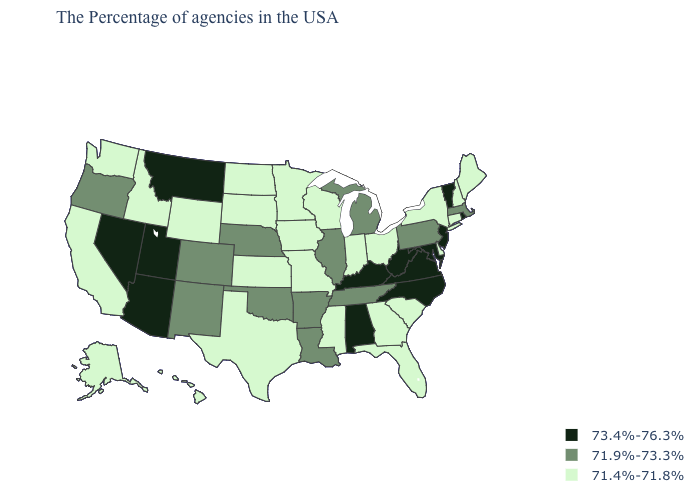What is the value of Missouri?
Give a very brief answer. 71.4%-71.8%. Which states have the highest value in the USA?
Short answer required. Rhode Island, Vermont, New Jersey, Maryland, Virginia, North Carolina, West Virginia, Kentucky, Alabama, Utah, Montana, Arizona, Nevada. How many symbols are there in the legend?
Give a very brief answer. 3. Does Tennessee have a lower value than Colorado?
Concise answer only. No. Name the states that have a value in the range 73.4%-76.3%?
Quick response, please. Rhode Island, Vermont, New Jersey, Maryland, Virginia, North Carolina, West Virginia, Kentucky, Alabama, Utah, Montana, Arizona, Nevada. How many symbols are there in the legend?
Quick response, please. 3. Does Arizona have a lower value than Kansas?
Write a very short answer. No. Does Georgia have the lowest value in the USA?
Be succinct. Yes. What is the value of Maryland?
Quick response, please. 73.4%-76.3%. Name the states that have a value in the range 71.4%-71.8%?
Keep it brief. Maine, New Hampshire, Connecticut, New York, Delaware, South Carolina, Ohio, Florida, Georgia, Indiana, Wisconsin, Mississippi, Missouri, Minnesota, Iowa, Kansas, Texas, South Dakota, North Dakota, Wyoming, Idaho, California, Washington, Alaska, Hawaii. What is the lowest value in states that border Arkansas?
Short answer required. 71.4%-71.8%. What is the value of Hawaii?
Give a very brief answer. 71.4%-71.8%. Name the states that have a value in the range 71.9%-73.3%?
Answer briefly. Massachusetts, Pennsylvania, Michigan, Tennessee, Illinois, Louisiana, Arkansas, Nebraska, Oklahoma, Colorado, New Mexico, Oregon. Which states have the lowest value in the MidWest?
Concise answer only. Ohio, Indiana, Wisconsin, Missouri, Minnesota, Iowa, Kansas, South Dakota, North Dakota. 